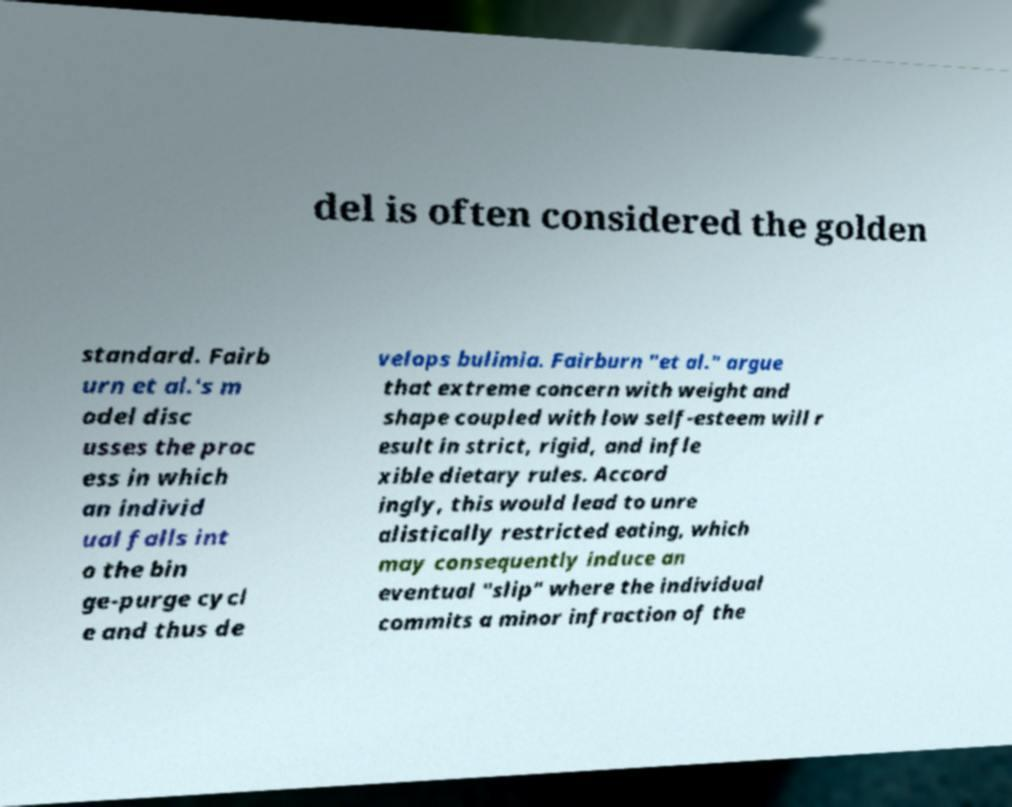There's text embedded in this image that I need extracted. Can you transcribe it verbatim? del is often considered the golden standard. Fairb urn et al.'s m odel disc usses the proc ess in which an individ ual falls int o the bin ge-purge cycl e and thus de velops bulimia. Fairburn "et al." argue that extreme concern with weight and shape coupled with low self-esteem will r esult in strict, rigid, and infle xible dietary rules. Accord ingly, this would lead to unre alistically restricted eating, which may consequently induce an eventual "slip" where the individual commits a minor infraction of the 